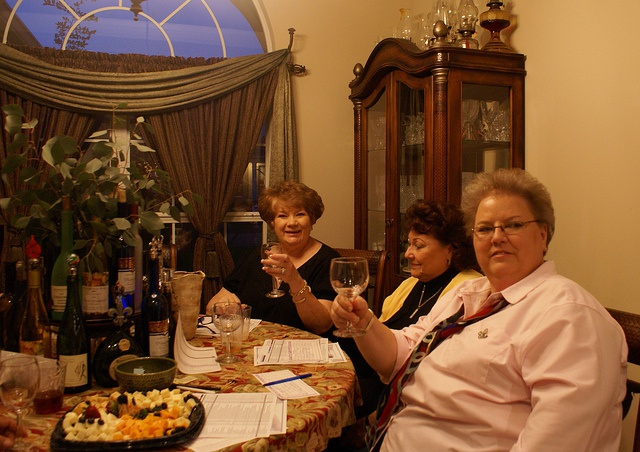Describe the objects in this image and their specific colors. I can see dining table in maroon, black, brown, and tan tones, people in maroon, tan, brown, and salmon tones, potted plant in maroon, black, and olive tones, people in maroon, black, and brown tones, and people in maroon, black, brown, and orange tones in this image. 